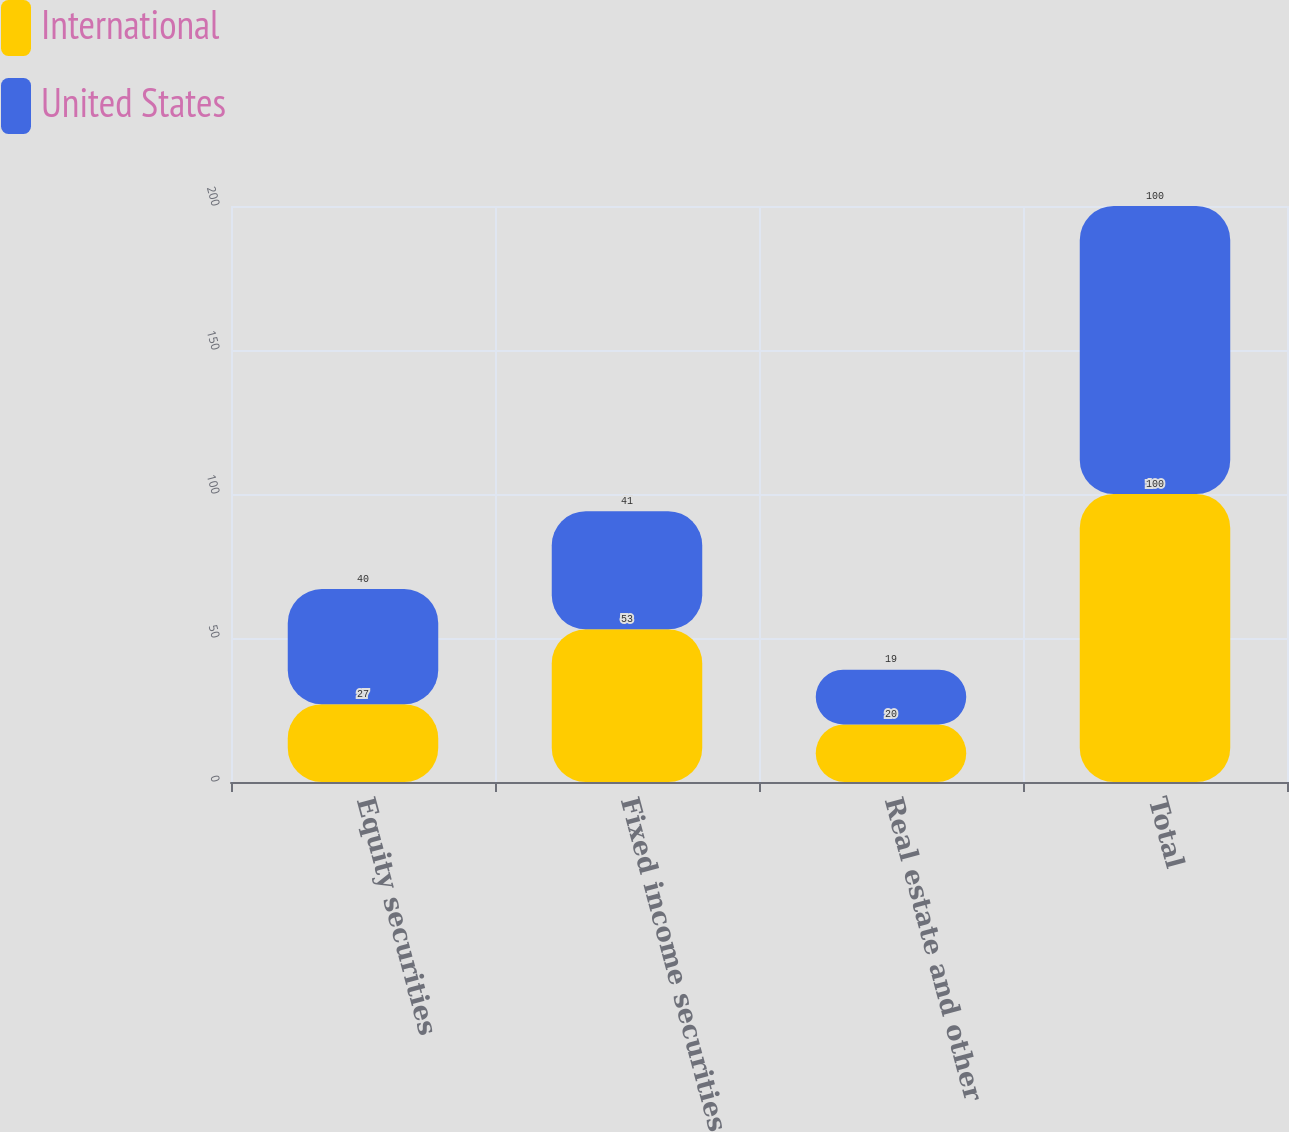Convert chart to OTSL. <chart><loc_0><loc_0><loc_500><loc_500><stacked_bar_chart><ecel><fcel>Equity securities<fcel>Fixed income securities<fcel>Real estate and other<fcel>Total<nl><fcel>International<fcel>27<fcel>53<fcel>20<fcel>100<nl><fcel>United States<fcel>40<fcel>41<fcel>19<fcel>100<nl></chart> 